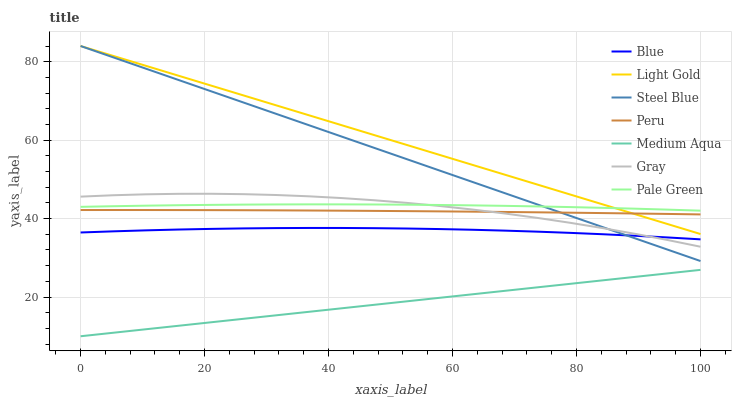Does Medium Aqua have the minimum area under the curve?
Answer yes or no. Yes. Does Light Gold have the maximum area under the curve?
Answer yes or no. Yes. Does Gray have the minimum area under the curve?
Answer yes or no. No. Does Gray have the maximum area under the curve?
Answer yes or no. No. Is Medium Aqua the smoothest?
Answer yes or no. Yes. Is Gray the roughest?
Answer yes or no. Yes. Is Steel Blue the smoothest?
Answer yes or no. No. Is Steel Blue the roughest?
Answer yes or no. No. Does Gray have the lowest value?
Answer yes or no. No. Does Light Gold have the highest value?
Answer yes or no. Yes. Does Gray have the highest value?
Answer yes or no. No. Is Blue less than Peru?
Answer yes or no. Yes. Is Peru greater than Blue?
Answer yes or no. Yes. Does Pale Green intersect Steel Blue?
Answer yes or no. Yes. Is Pale Green less than Steel Blue?
Answer yes or no. No. Is Pale Green greater than Steel Blue?
Answer yes or no. No. Does Blue intersect Peru?
Answer yes or no. No. 